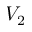<formula> <loc_0><loc_0><loc_500><loc_500>V _ { 2 }</formula> 